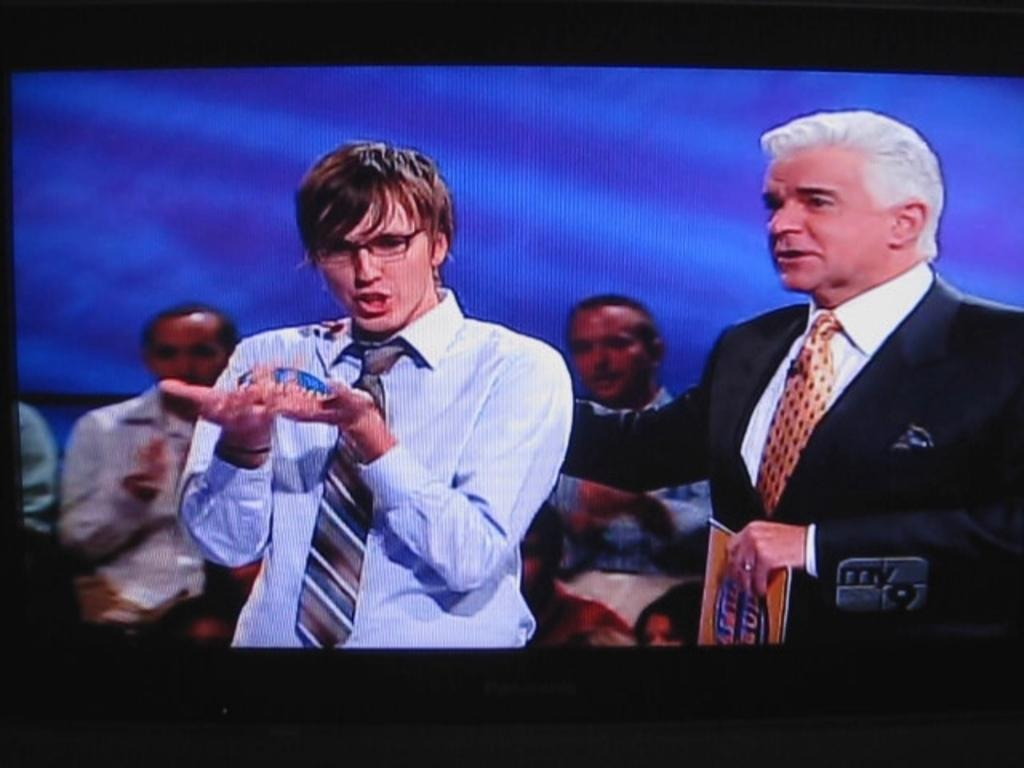<image>
Present a compact description of the photo's key features. A screen shot from a TV programming on my 9. 